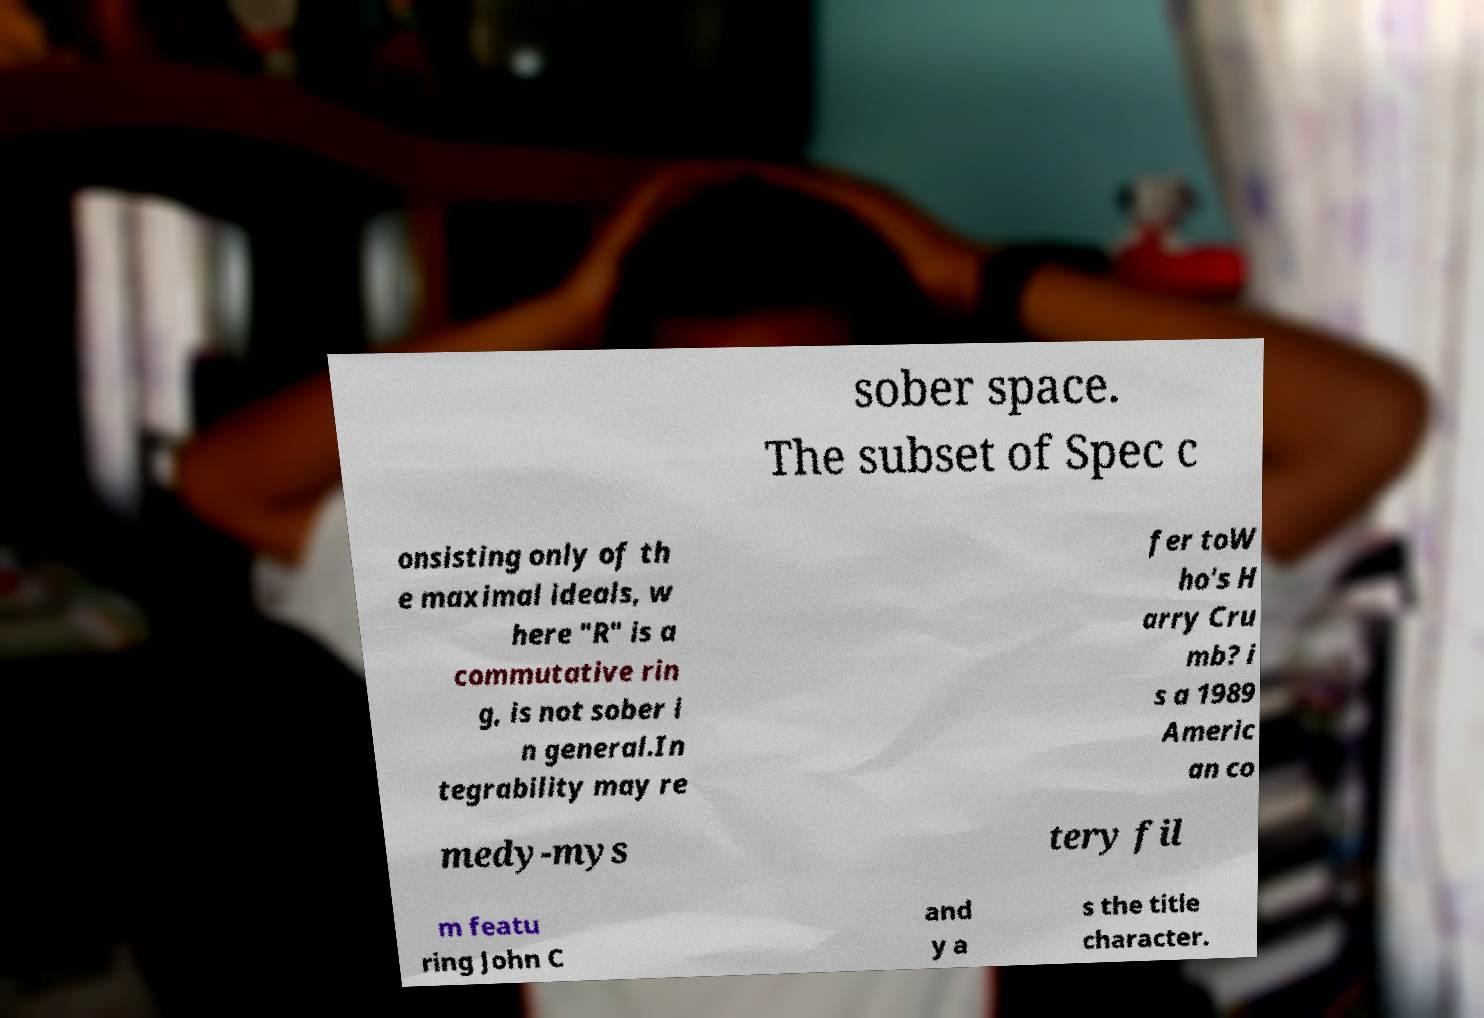Can you read and provide the text displayed in the image?This photo seems to have some interesting text. Can you extract and type it out for me? sober space. The subset of Spec c onsisting only of th e maximal ideals, w here "R" is a commutative rin g, is not sober i n general.In tegrability may re fer toW ho's H arry Cru mb? i s a 1989 Americ an co medy-mys tery fil m featu ring John C and y a s the title character. 